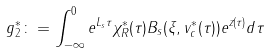Convert formula to latex. <formula><loc_0><loc_0><loc_500><loc_500>g _ { 2 } ^ { * } \colon = \int ^ { 0 } _ { - \infty } e ^ { L _ { s } \tau } \chi _ { R } ^ { * } ( \tau ) B _ { s } ( \xi , v ^ { * } _ { c } ( \tau ) ) e ^ { z ( \tau ) } d \tau</formula> 